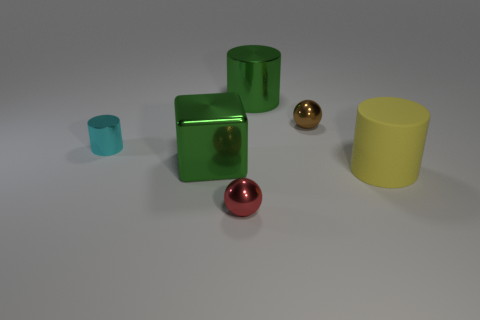The shiny thing that is the same color as the big cube is what size?
Offer a very short reply. Large. How many blue objects are matte cylinders or big shiny cylinders?
Give a very brief answer. 0. What shape is the big metallic object that is the same color as the metal cube?
Offer a terse response. Cylinder. Are there any other things that are made of the same material as the green block?
Your answer should be very brief. Yes. Does the big green thing in front of the tiny cyan thing have the same shape as the large green shiny thing that is behind the brown ball?
Keep it short and to the point. No. How many large purple metal blocks are there?
Offer a terse response. 0. What shape is the small red thing that is made of the same material as the brown ball?
Make the answer very short. Sphere. Is there any other thing of the same color as the large rubber cylinder?
Provide a short and direct response. No. There is a big block; is its color the same as the small metal thing on the right side of the tiny red metal ball?
Offer a very short reply. No. Is the number of large cylinders to the right of the big yellow cylinder less than the number of large blocks?
Your response must be concise. Yes. 